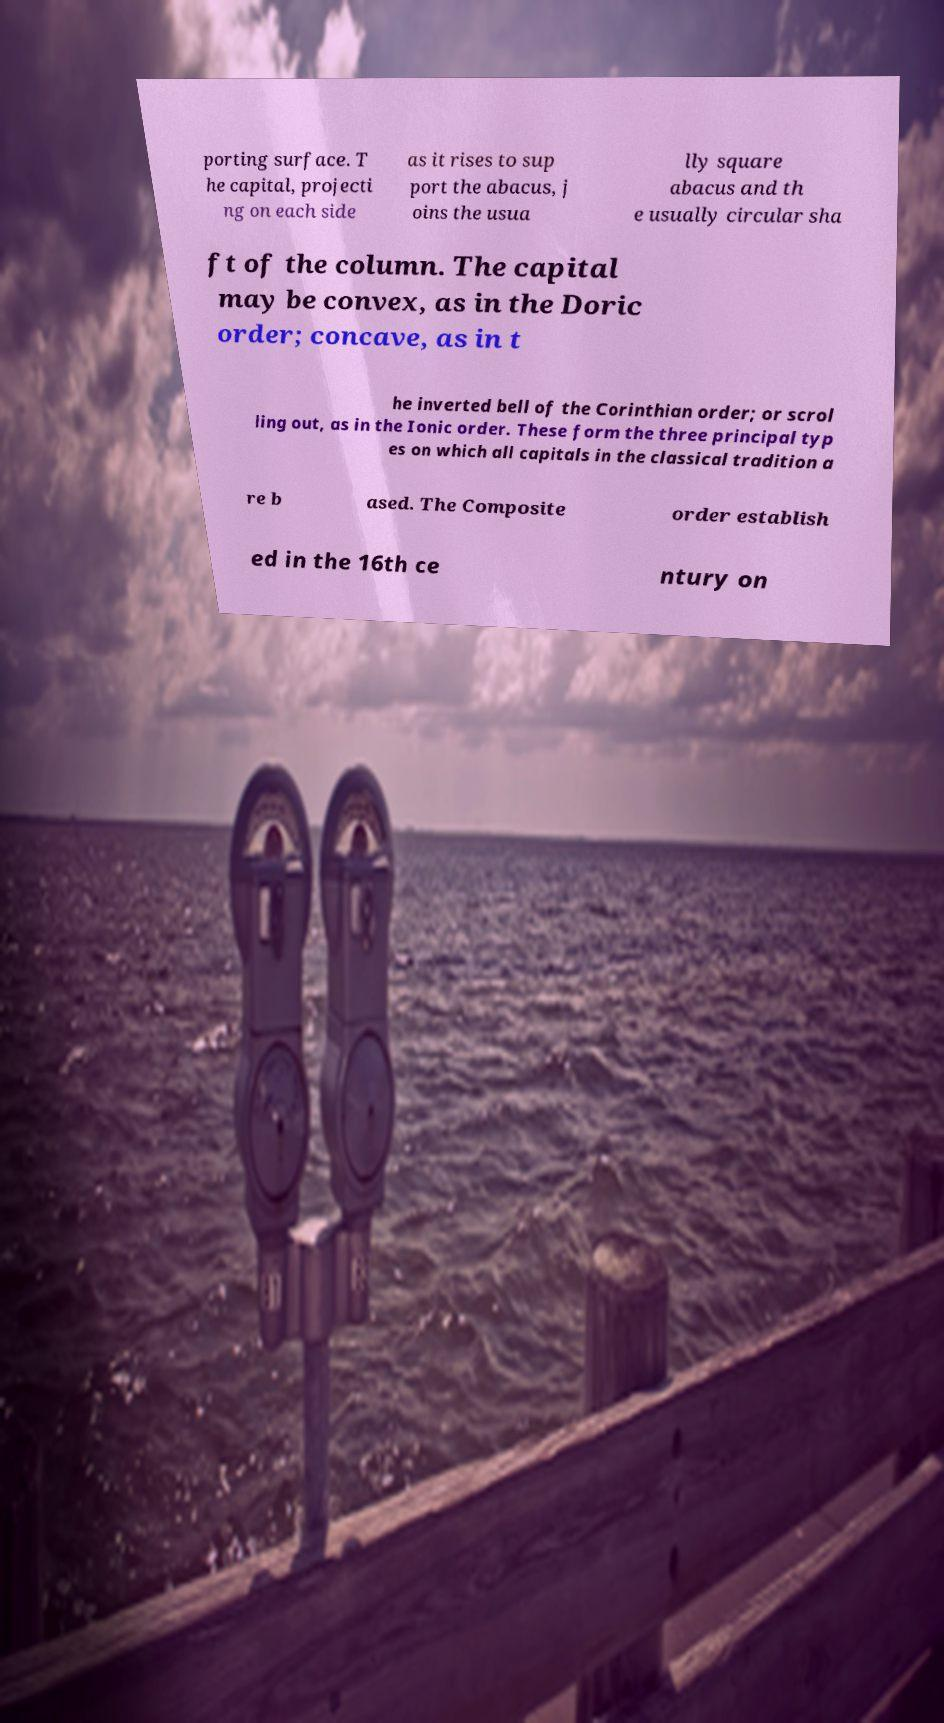What messages or text are displayed in this image? I need them in a readable, typed format. porting surface. T he capital, projecti ng on each side as it rises to sup port the abacus, j oins the usua lly square abacus and th e usually circular sha ft of the column. The capital may be convex, as in the Doric order; concave, as in t he inverted bell of the Corinthian order; or scrol ling out, as in the Ionic order. These form the three principal typ es on which all capitals in the classical tradition a re b ased. The Composite order establish ed in the 16th ce ntury on 